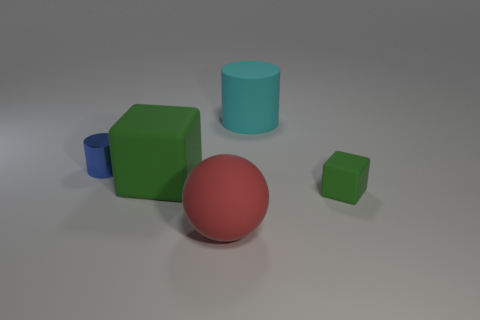Add 2 big gray cubes. How many objects exist? 7 Subtract 1 cylinders. How many cylinders are left? 1 Subtract all cyan cylinders. How many cylinders are left? 1 Subtract all cubes. How many objects are left? 3 Subtract all brown blocks. Subtract all red spheres. How many blocks are left? 2 Subtract all tiny cyan rubber things. Subtract all small cylinders. How many objects are left? 4 Add 2 rubber blocks. How many rubber blocks are left? 4 Add 1 big cyan rubber objects. How many big cyan rubber objects exist? 2 Subtract 1 red balls. How many objects are left? 4 